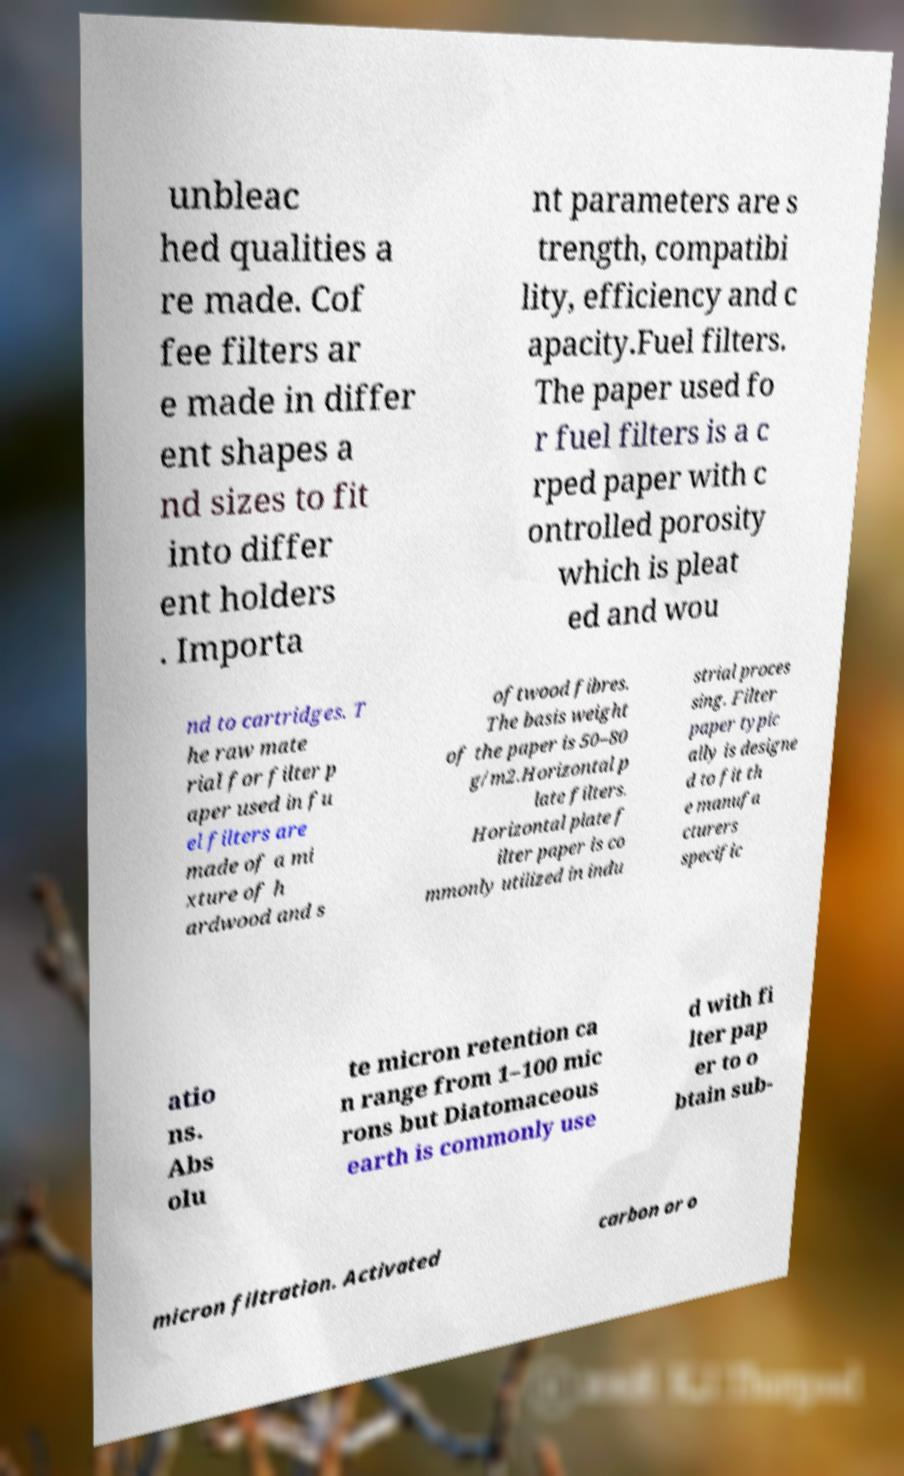Could you assist in decoding the text presented in this image and type it out clearly? unbleac hed qualities a re made. Cof fee filters ar e made in differ ent shapes a nd sizes to fit into differ ent holders . Importa nt parameters are s trength, compatibi lity, efficiency and c apacity.Fuel filters. The paper used fo r fuel filters is a c rped paper with c ontrolled porosity which is pleat ed and wou nd to cartridges. T he raw mate rial for filter p aper used in fu el filters are made of a mi xture of h ardwood and s oftwood fibres. The basis weight of the paper is 50–80 g/m2.Horizontal p late filters. Horizontal plate f ilter paper is co mmonly utilized in indu strial proces sing. Filter paper typic ally is designe d to fit th e manufa cturers specific atio ns. Abs olu te micron retention ca n range from 1–100 mic rons but Diatomaceous earth is commonly use d with fi lter pap er to o btain sub- micron filtration. Activated carbon or o 